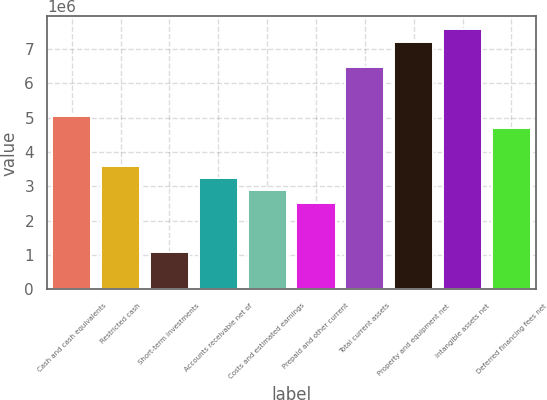<chart> <loc_0><loc_0><loc_500><loc_500><bar_chart><fcel>Cash and cash equivalents<fcel>Restricted cash<fcel>Short-term investments<fcel>Accounts receivable net of<fcel>Costs and estimated earnings<fcel>Prepaid and other current<fcel>Total current assets<fcel>Property and equipment net<fcel>Intangible assets net<fcel>Deferred financing fees net<nl><fcel>5.04876e+06<fcel>3.6064e+06<fcel>1.08226e+06<fcel>3.24581e+06<fcel>2.88522e+06<fcel>2.52462e+06<fcel>6.49113e+06<fcel>7.21231e+06<fcel>7.5729e+06<fcel>4.68817e+06<nl></chart> 